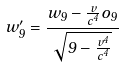Convert formula to latex. <formula><loc_0><loc_0><loc_500><loc_500>w _ { 9 } ^ { \prime } = \frac { w _ { 9 } - \frac { v } { c ^ { 4 } } o _ { 9 } } { \sqrt { 9 - \frac { v ^ { 4 } } { c ^ { 4 } } } }</formula> 